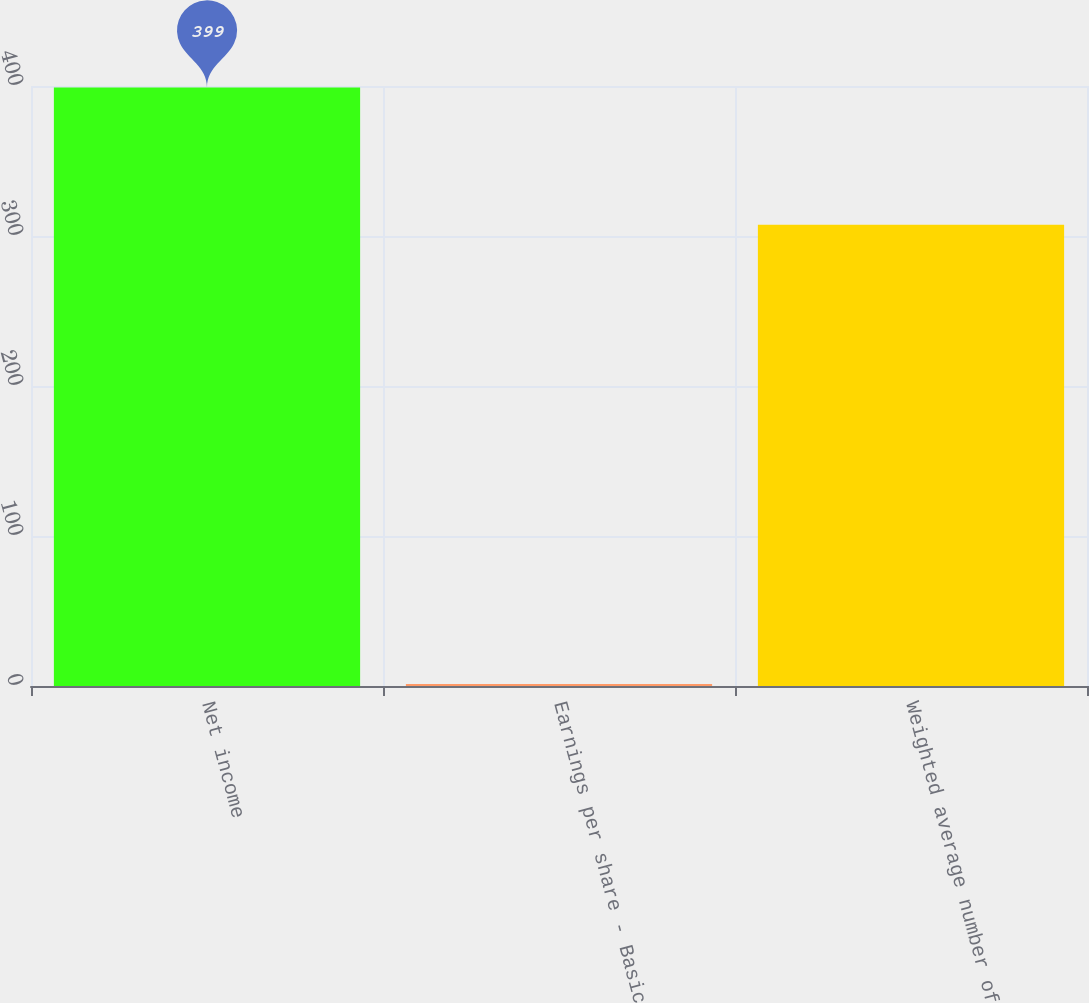<chart> <loc_0><loc_0><loc_500><loc_500><bar_chart><fcel>Net income<fcel>Earnings per share - Basic<fcel>Weighted average number of<nl><fcel>399<fcel>1.3<fcel>307.57<nl></chart> 